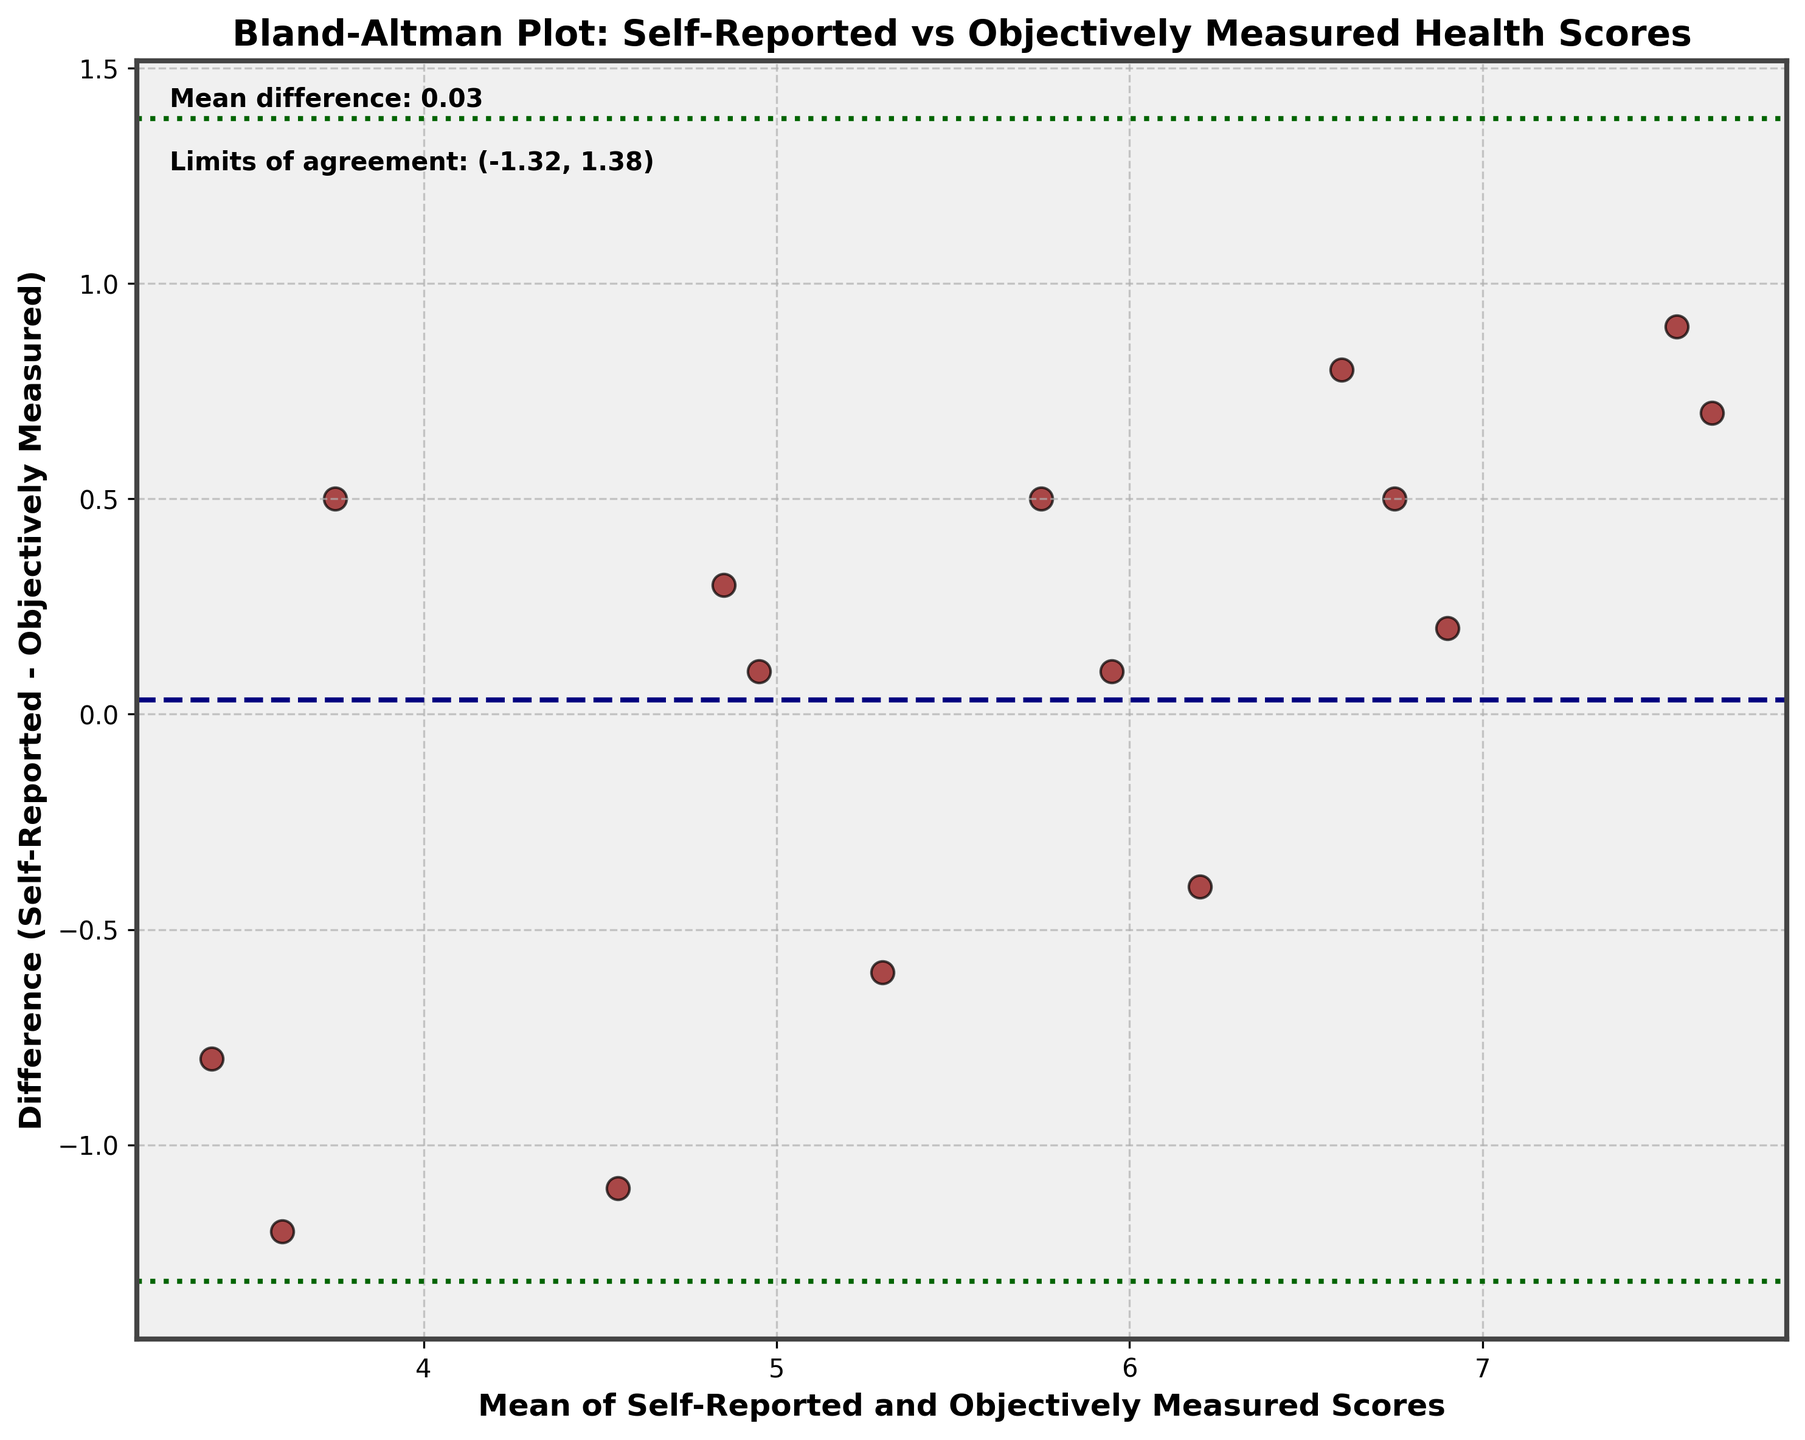What is the title of the plot? The title of the plot is located at the top center of the figure. It states what the plot is about. The title is "Bland-Altman Plot: Self-Reported vs Objectively Measured Health Scores".
Answer: Bland-Altman Plot: Self-Reported vs Objectively Measured Health Scores How many data points are shown in the plot? Data points in the plot are represented by dark red circles. By counting all the circles, you can determine the number of data points.
Answer: 15 What is the mean difference between self-reported and objectively measured health scores? The mean difference is the horizontal dashed line in the plot labeled with text on the figure itself. It is shown as slightly below 0.
Answer: ~ -0.18 What are the limits of agreement for the differences? The limits of agreement are represented by the two horizontally dashed green lines. They are also labeled with text on the figure itself.
Answer: (-1.82, 1.46) Which data point shows the largest difference between self-reported and objectively measured scores? Look for the data point furthest from the horizontal mean difference line, either above or below. The point furthest above the line has the largest positive difference, and the point furthest below has the largest negative difference.
Answer: Mrs. Clark How does the mean difference compare to zero? The mean difference line is shown slightly below zero on the vertical axis, indicating that it is negative. So, comparing it to zero confirms that it is less than zero.
Answer: Less than zero Is there a general trend visible in the agreement of self-reported and objectively measured scores? By examining the scattered points relative to the mean difference line, you can observe any visible trends. If the points are equally scattered above and below the mean difference line, it indicates no systematic trend.
Answer: No systematic trend Are there more data points above or below the mean difference line? Count the number of points above the horizontal mean difference line and then count the points below it. Compare these two numbers.
Answer: More points below What does the spread of the points indicate about variability in differences? The spread of points around the mean difference line and within the limits of agreement can give information about the consistency and variability of the differences. A wide spread indicates higher variability.
Answer: High variability How well do the self-reported and objectively measured scores agree overall? The degree of scatter and how close the differences are to the mean difference line and within the limits of agreement give insights into the agreement between the scores. If most points are close to the mean difference line, it indicates good agreement.
Answer: Moderate agreement 